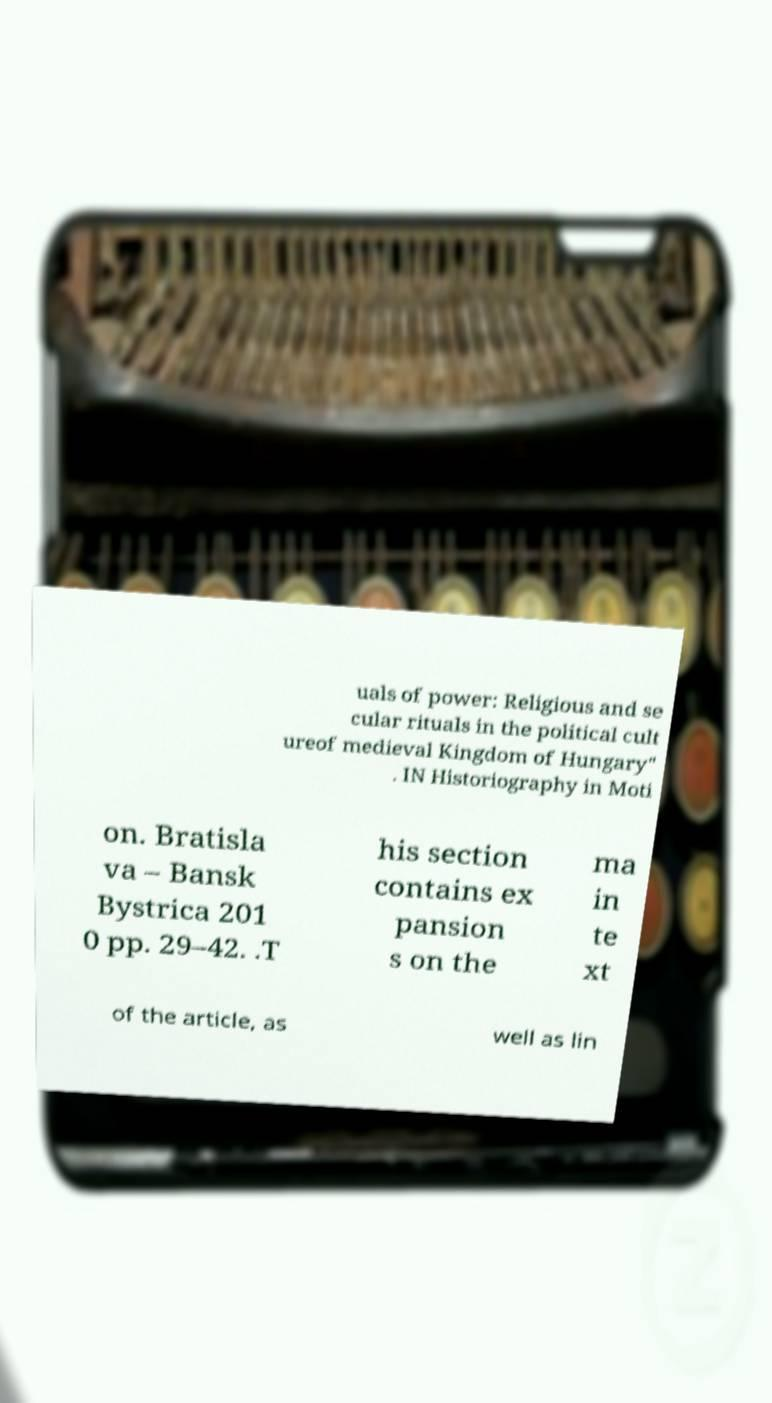I need the written content from this picture converted into text. Can you do that? uals of power: Religious and se cular rituals in the political cult ureof medieval Kingdom of Hungary" . IN Historiography in Moti on. Bratisla va – Bansk Bystrica 201 0 pp. 29–42. .T his section contains ex pansion s on the ma in te xt of the article, as well as lin 